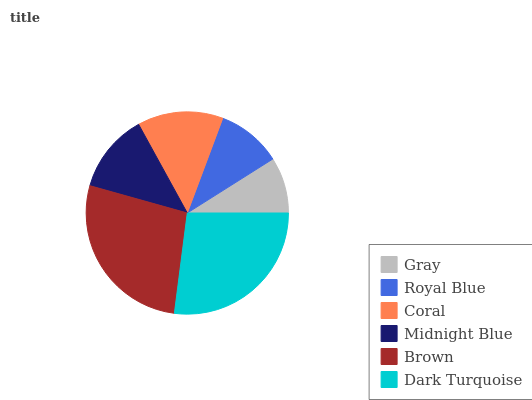Is Gray the minimum?
Answer yes or no. Yes. Is Brown the maximum?
Answer yes or no. Yes. Is Royal Blue the minimum?
Answer yes or no. No. Is Royal Blue the maximum?
Answer yes or no. No. Is Royal Blue greater than Gray?
Answer yes or no. Yes. Is Gray less than Royal Blue?
Answer yes or no. Yes. Is Gray greater than Royal Blue?
Answer yes or no. No. Is Royal Blue less than Gray?
Answer yes or no. No. Is Coral the high median?
Answer yes or no. Yes. Is Midnight Blue the low median?
Answer yes or no. Yes. Is Royal Blue the high median?
Answer yes or no. No. Is Gray the low median?
Answer yes or no. No. 